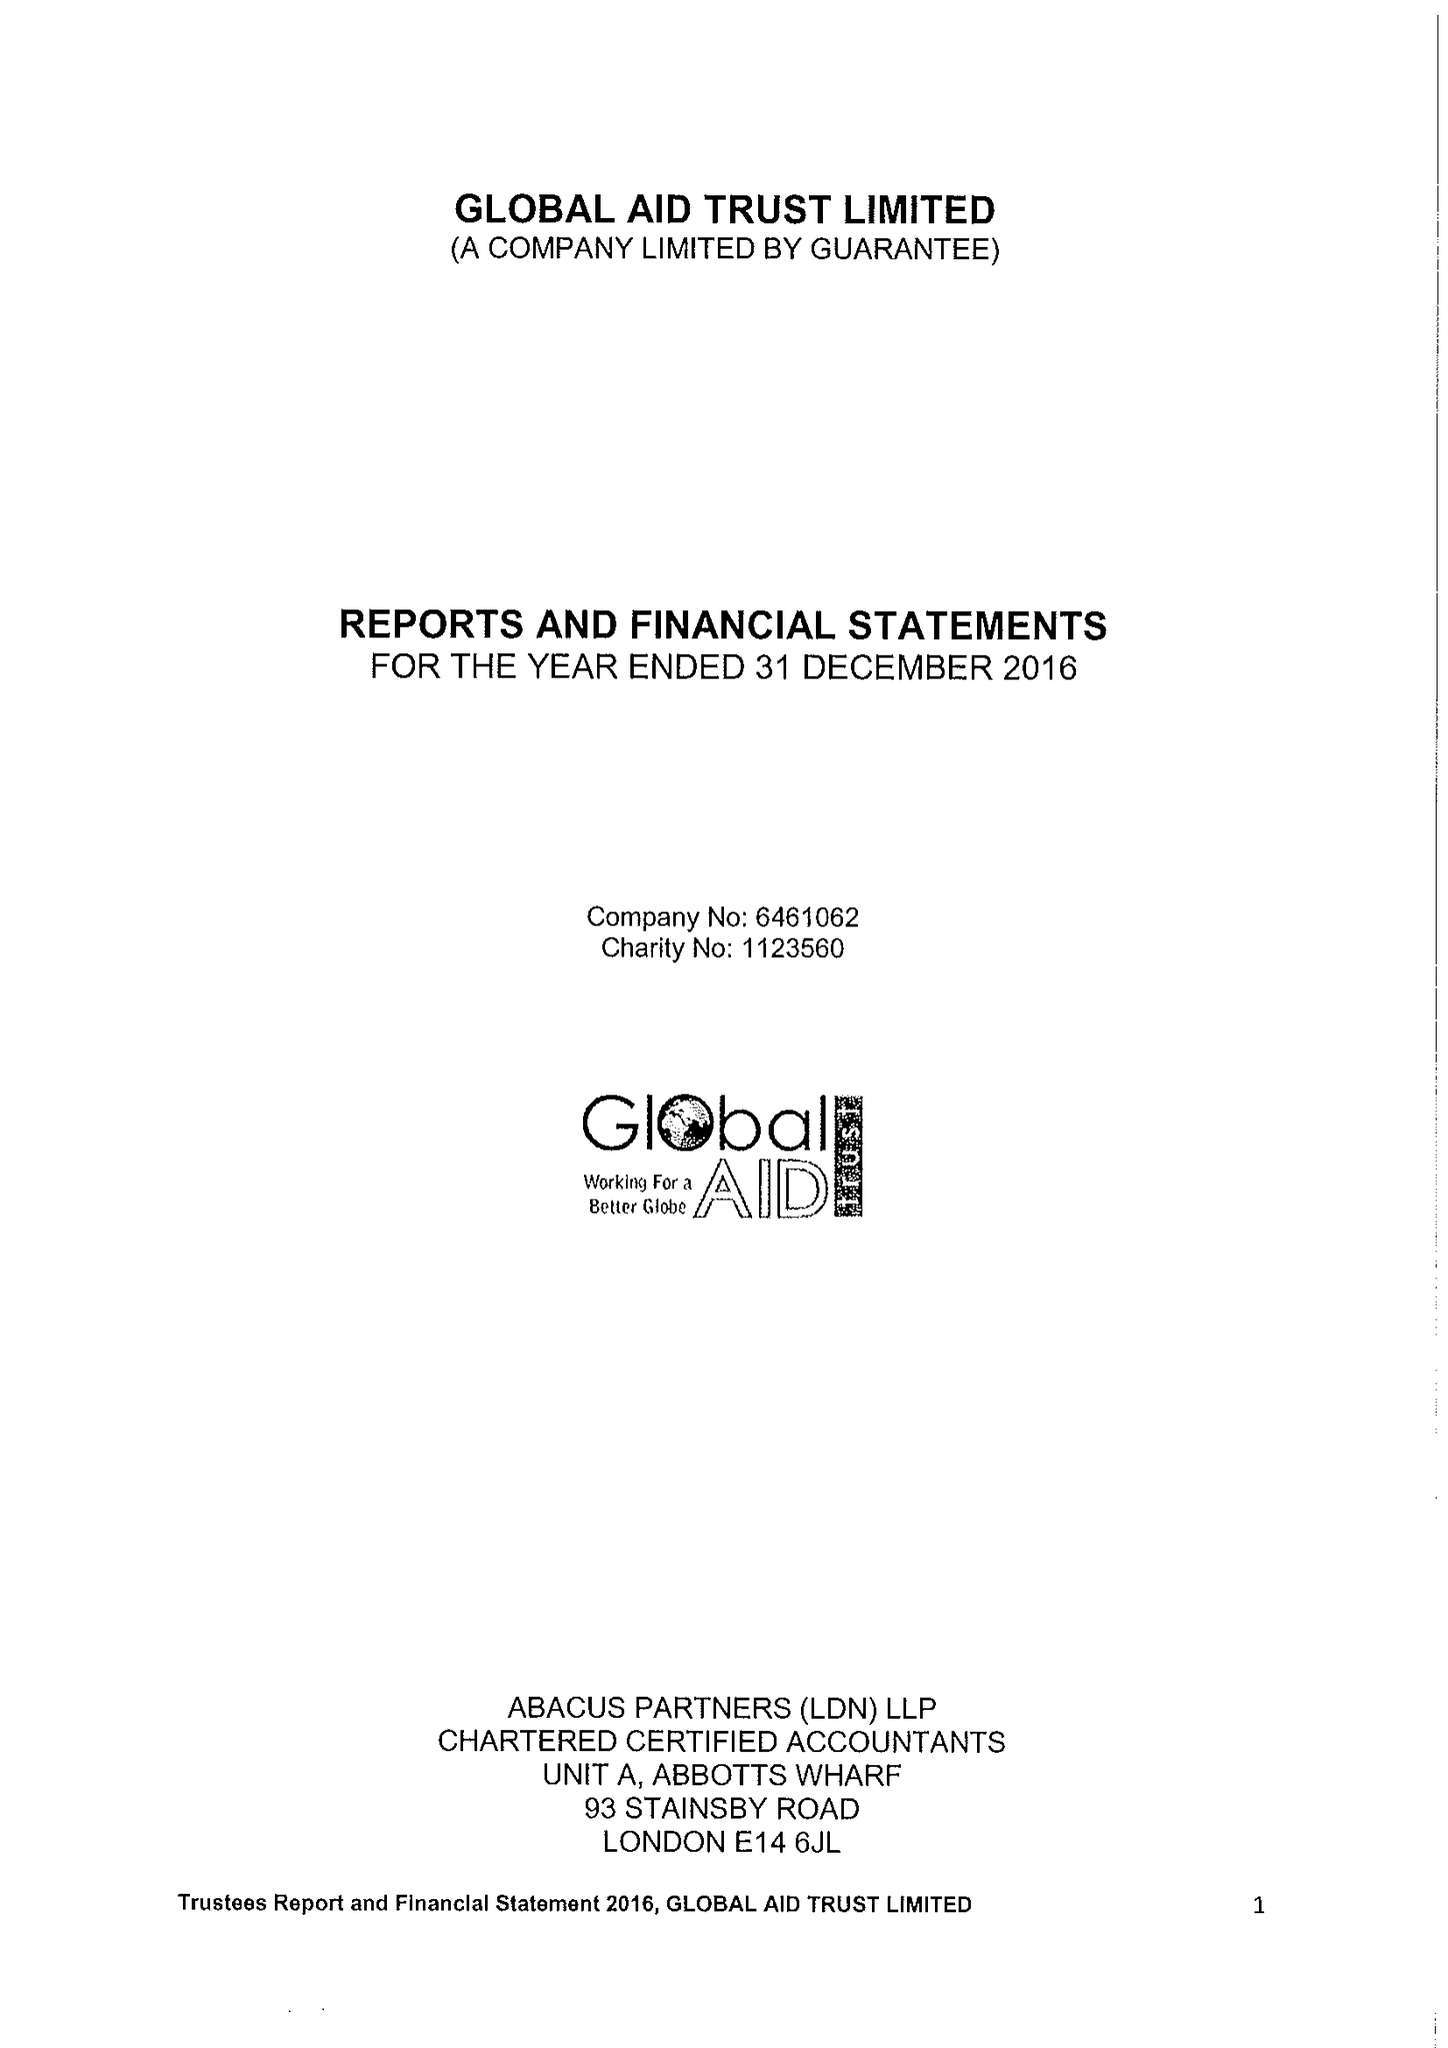What is the value for the address__street_line?
Answer the question using a single word or phrase. 80A ASHFIELD STREET 